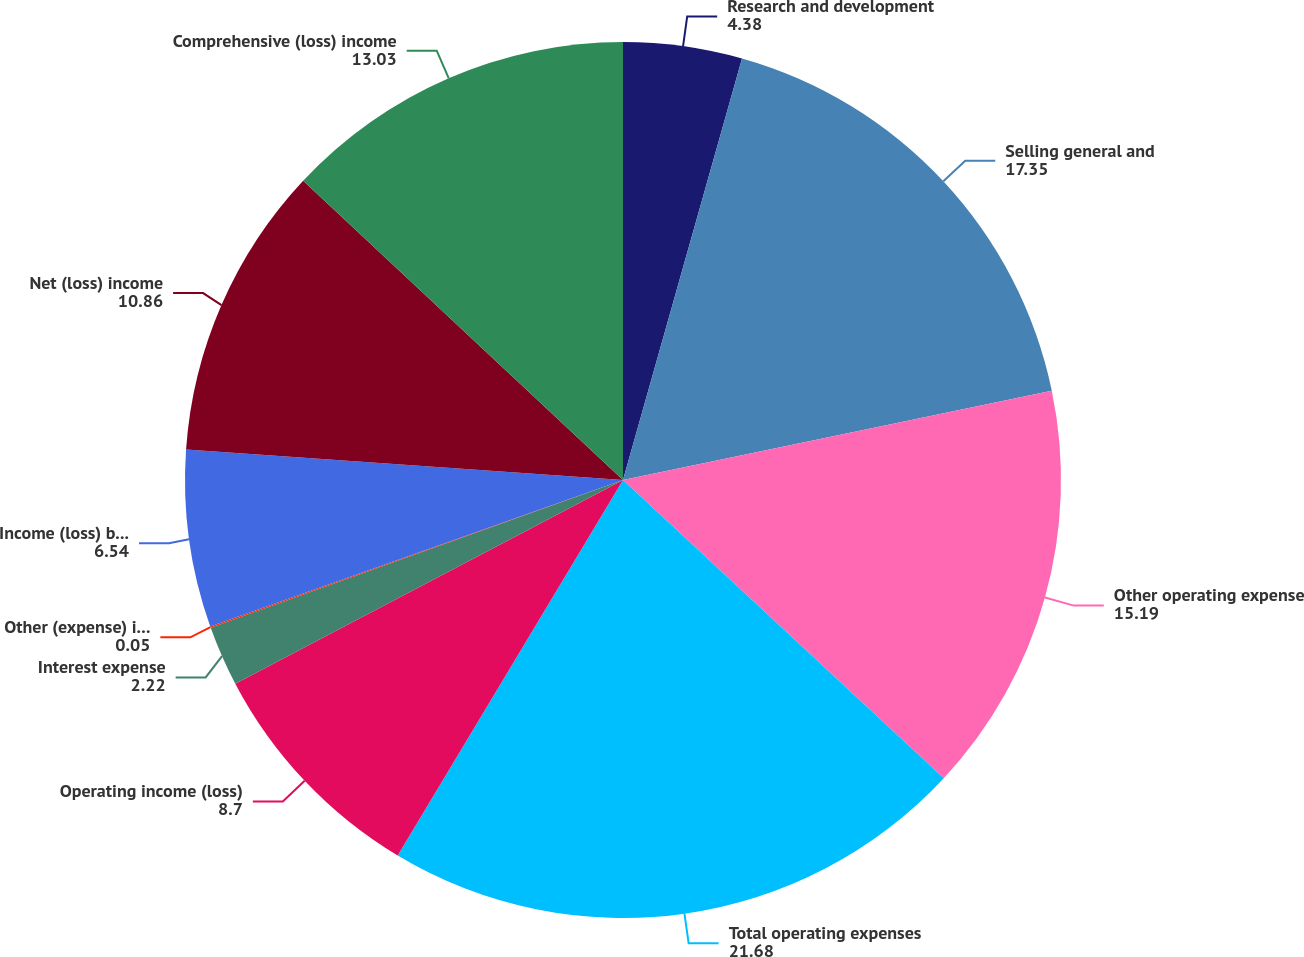<chart> <loc_0><loc_0><loc_500><loc_500><pie_chart><fcel>Research and development<fcel>Selling general and<fcel>Other operating expense<fcel>Total operating expenses<fcel>Operating income (loss)<fcel>Interest expense<fcel>Other (expense) income<fcel>Income (loss) before income<fcel>Net (loss) income<fcel>Comprehensive (loss) income<nl><fcel>4.38%<fcel>17.35%<fcel>15.19%<fcel>21.68%<fcel>8.7%<fcel>2.22%<fcel>0.05%<fcel>6.54%<fcel>10.86%<fcel>13.03%<nl></chart> 